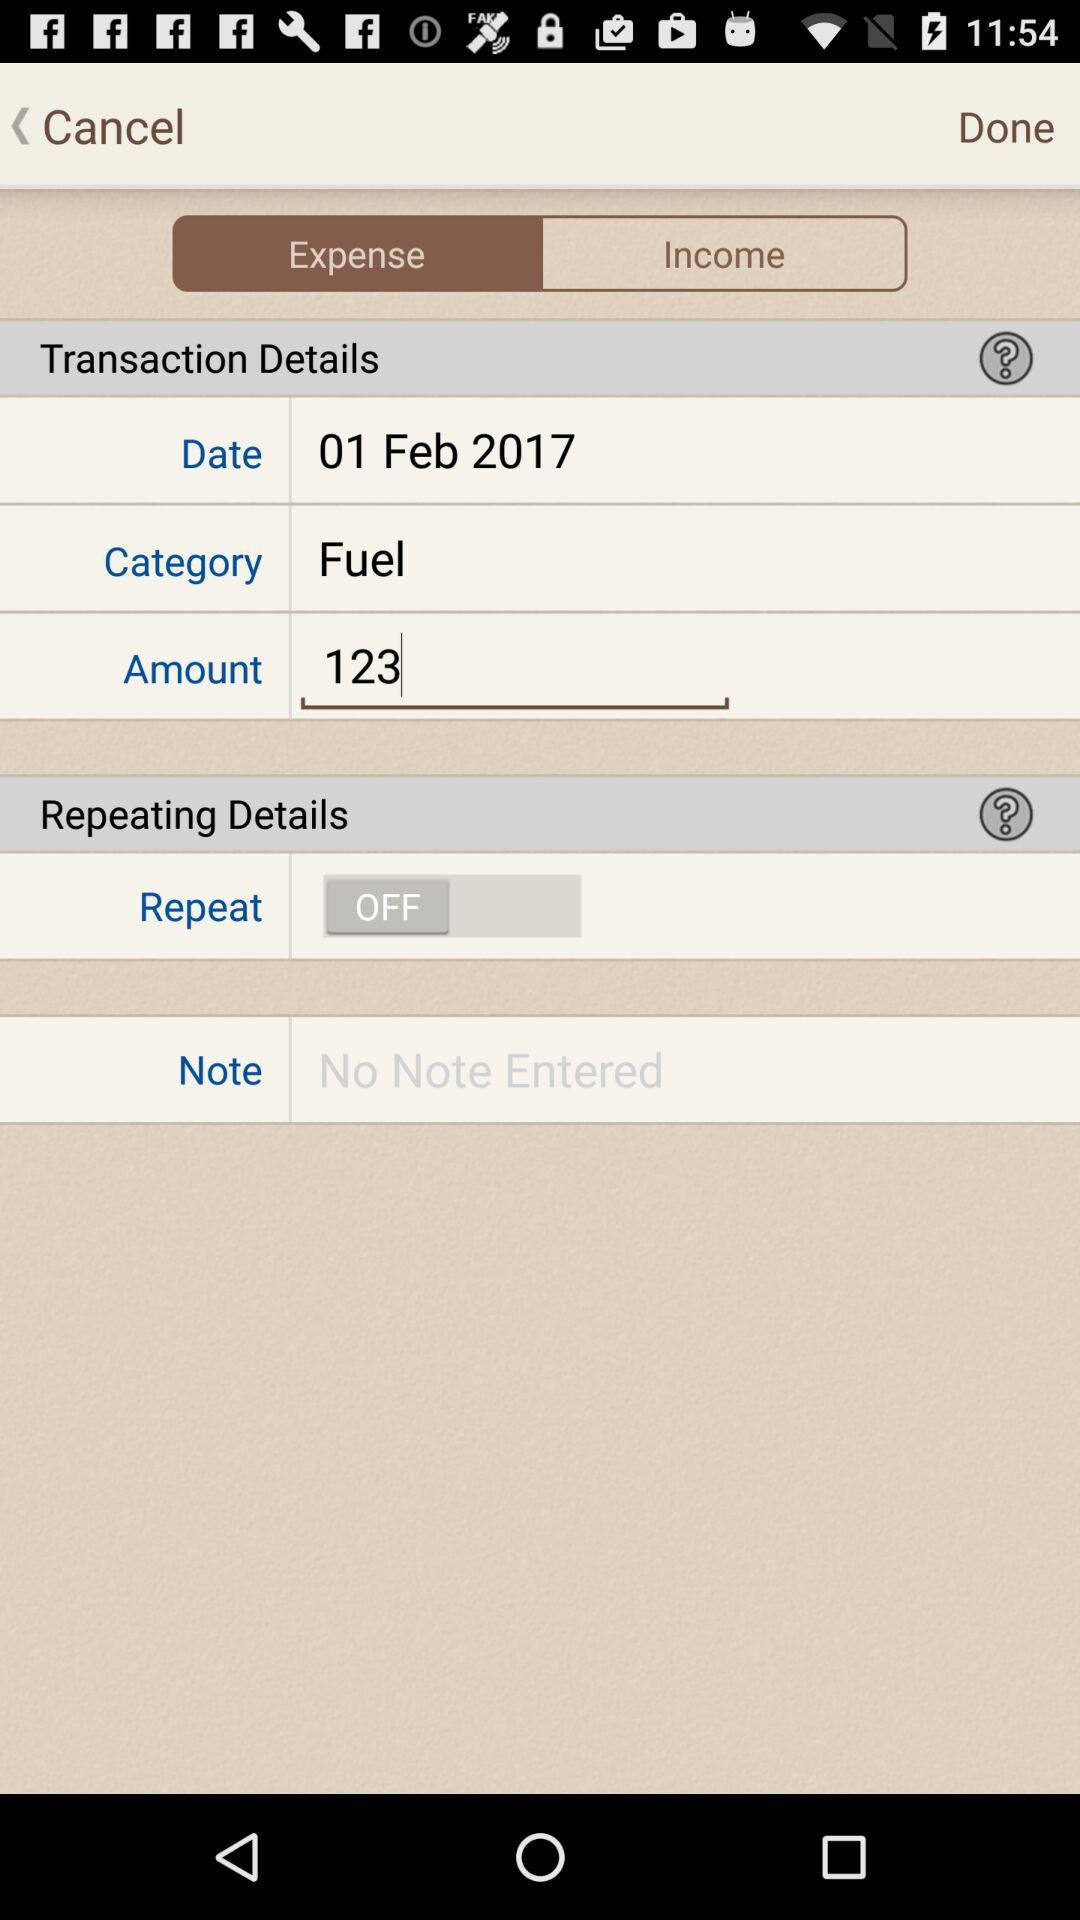What is the status of the "Repeat"? The status is "off". 